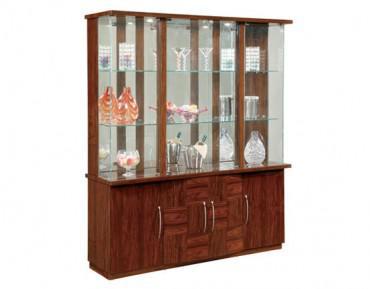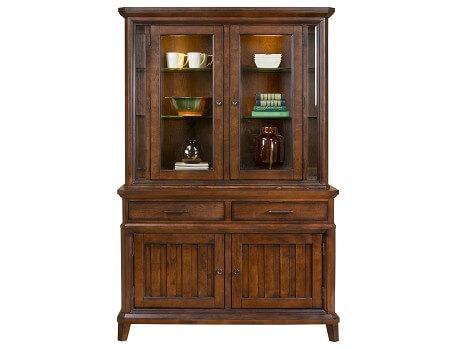The first image is the image on the left, the second image is the image on the right. For the images shown, is this caption "All cabinets shown are rich brown wood tones." true? Answer yes or no. Yes. 